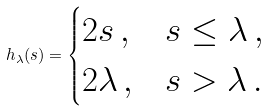<formula> <loc_0><loc_0><loc_500><loc_500>h _ { \lambda } ( s ) = \begin{cases} 2 s \, , & s \leq \lambda \, , \\ 2 \lambda \, , & s > \lambda \, . \end{cases}</formula> 